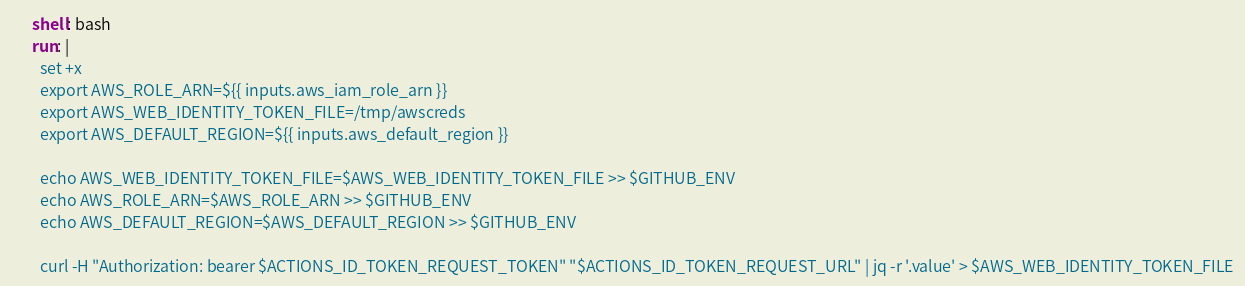<code> <loc_0><loc_0><loc_500><loc_500><_YAML_>      shell: bash
      run: |
        set +x
        export AWS_ROLE_ARN=${{ inputs.aws_iam_role_arn }}
        export AWS_WEB_IDENTITY_TOKEN_FILE=/tmp/awscreds
        export AWS_DEFAULT_REGION=${{ inputs.aws_default_region }}

        echo AWS_WEB_IDENTITY_TOKEN_FILE=$AWS_WEB_IDENTITY_TOKEN_FILE >> $GITHUB_ENV
        echo AWS_ROLE_ARN=$AWS_ROLE_ARN >> $GITHUB_ENV
        echo AWS_DEFAULT_REGION=$AWS_DEFAULT_REGION >> $GITHUB_ENV

        curl -H "Authorization: bearer $ACTIONS_ID_TOKEN_REQUEST_TOKEN" "$ACTIONS_ID_TOKEN_REQUEST_URL" | jq -r '.value' > $AWS_WEB_IDENTITY_TOKEN_FILE</code> 